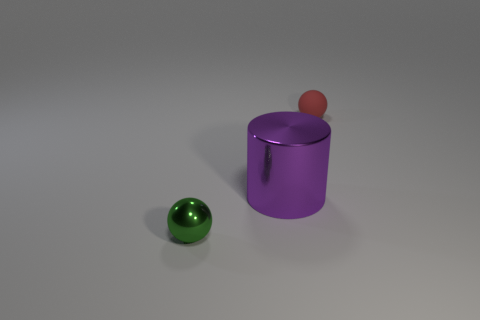How many objects are either red matte things or objects that are behind the small shiny thing?
Your answer should be compact. 2. How many small rubber objects are to the right of the shiny sphere?
Your answer should be very brief. 1. There is a large thing that is the same material as the green ball; what is its color?
Your answer should be very brief. Purple. What number of matte objects are purple cylinders or large brown things?
Your answer should be compact. 0. Is the large cylinder made of the same material as the green sphere?
Offer a very short reply. Yes. What shape is the thing that is behind the big purple shiny object?
Provide a short and direct response. Sphere. Is there a small red matte ball that is in front of the small ball that is in front of the big metal cylinder?
Provide a succinct answer. No. Is there a yellow object of the same size as the shiny sphere?
Your answer should be compact. No. The purple metal cylinder has what size?
Your answer should be very brief. Large. What is the size of the ball on the right side of the tiny ball to the left of the purple shiny cylinder?
Your answer should be very brief. Small. 